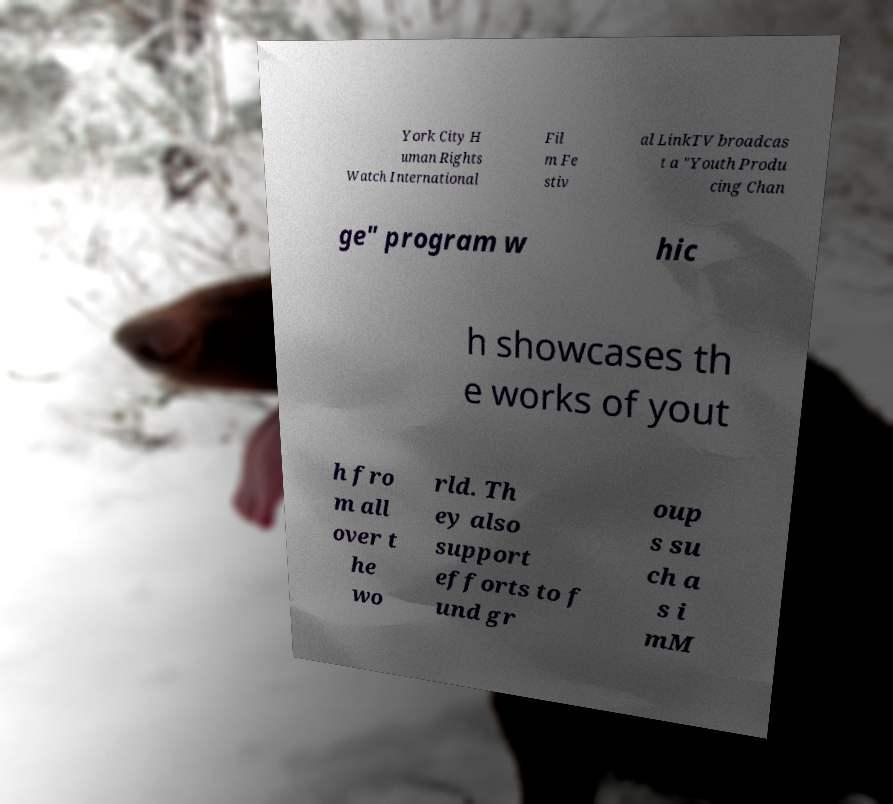Please read and relay the text visible in this image. What does it say? York City H uman Rights Watch International Fil m Fe stiv al LinkTV broadcas t a "Youth Produ cing Chan ge" program w hic h showcases th e works of yout h fro m all over t he wo rld. Th ey also support efforts to f und gr oup s su ch a s i mM 